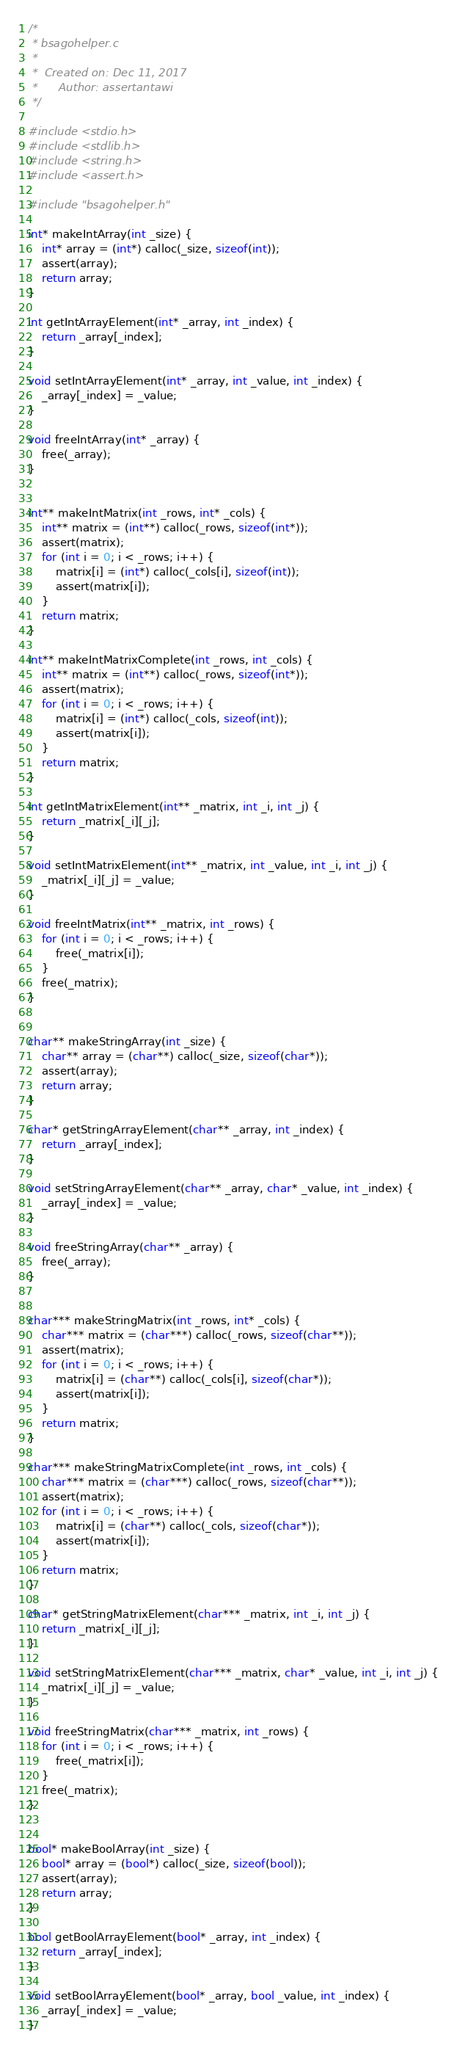<code> <loc_0><loc_0><loc_500><loc_500><_C_>/*
 * bsagohelper.c
 *
 *  Created on: Dec 11, 2017
 *      Author: assertantawi
 */

#include <stdio.h>
#include <stdlib.h>
#include <string.h>
#include <assert.h>

#include "bsagohelper.h"

int* makeIntArray(int _size) {
	int* array = (int*) calloc(_size, sizeof(int));
	assert(array);
	return array;
}

int getIntArrayElement(int* _array, int _index) {
	return _array[_index];
}

void setIntArrayElement(int* _array, int _value, int _index) {
	_array[_index] = _value;
}

void freeIntArray(int* _array) {
	free(_array);
}


int** makeIntMatrix(int _rows, int* _cols) {
	int** matrix = (int**) calloc(_rows, sizeof(int*));
	assert(matrix);
	for (int i = 0; i < _rows; i++) {
		matrix[i] = (int*) calloc(_cols[i], sizeof(int));
		assert(matrix[i]);
	}
	return matrix;
}

int** makeIntMatrixComplete(int _rows, int _cols) {
	int** matrix = (int**) calloc(_rows, sizeof(int*));
	assert(matrix);
	for (int i = 0; i < _rows; i++) {
		matrix[i] = (int*) calloc(_cols, sizeof(int));
		assert(matrix[i]);
	}
	return matrix;
}

int getIntMatrixElement(int** _matrix, int _i, int _j) {
	return _matrix[_i][_j];
}

void setIntMatrixElement(int** _matrix, int _value, int _i, int _j) {
	_matrix[_i][_j] = _value;
}

void freeIntMatrix(int** _matrix, int _rows) {
	for (int i = 0; i < _rows; i++) {
		free(_matrix[i]);
	}
	free(_matrix);
}


char** makeStringArray(int _size) {
	char** array = (char**) calloc(_size, sizeof(char*));
	assert(array);
	return array;
}

char* getStringArrayElement(char** _array, int _index) {
	return _array[_index];
}

void setStringArrayElement(char** _array, char* _value, int _index) {
	_array[_index] = _value;
}

void freeStringArray(char** _array) {
	free(_array);
}


char*** makeStringMatrix(int _rows, int* _cols) {
	char*** matrix = (char***) calloc(_rows, sizeof(char**));
	assert(matrix);
	for (int i = 0; i < _rows; i++) {
		matrix[i] = (char**) calloc(_cols[i], sizeof(char*));
		assert(matrix[i]);
	}
	return matrix;
}

char*** makeStringMatrixComplete(int _rows, int _cols) {
	char*** matrix = (char***) calloc(_rows, sizeof(char**));
	assert(matrix);
	for (int i = 0; i < _rows; i++) {
		matrix[i] = (char**) calloc(_cols, sizeof(char*));
		assert(matrix[i]);
	}
	return matrix;
}

char* getStringMatrixElement(char*** _matrix, int _i, int _j) {
	return _matrix[_i][_j];
}

void setStringMatrixElement(char*** _matrix, char* _value, int _i, int _j) {
	_matrix[_i][_j] = _value;
}

void freeStringMatrix(char*** _matrix, int _rows) {
	for (int i = 0; i < _rows; i++) {
		free(_matrix[i]);
	}
	free(_matrix);
}


bool* makeBoolArray(int _size) {
	bool* array = (bool*) calloc(_size, sizeof(bool));
	assert(array);
	return array;
}

bool getBoolArrayElement(bool* _array, int _index) {
	return _array[_index];
}

void setBoolArrayElement(bool* _array, bool _value, int _index) {
	_array[_index] = _value;
}
</code> 